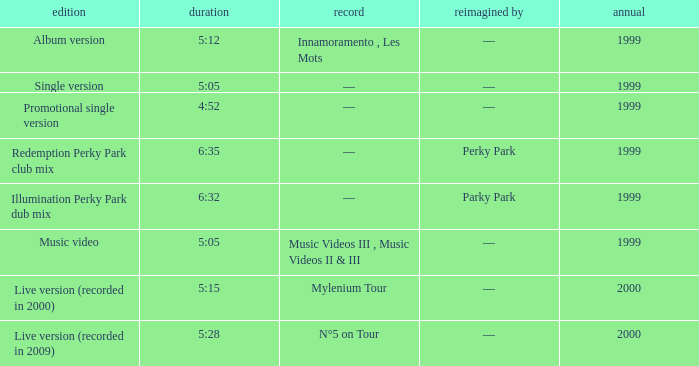What album is 5:15 long Live version (recorded in 2000). Write the full table. {'header': ['edition', 'duration', 'record', 'reimagined by', 'annual'], 'rows': [['Album version', '5:12', 'Innamoramento , Les Mots', '—', '1999'], ['Single version', '5:05', '—', '—', '1999'], ['Promotional single version', '4:52', '—', '—', '1999'], ['Redemption Perky Park club mix', '6:35', '—', 'Perky Park', '1999'], ['Illumination Perky Park dub mix', '6:32', '—', 'Parky Park', '1999'], ['Music video', '5:05', 'Music Videos III , Music Videos II & III', '—', '1999'], ['Live version (recorded in 2000)', '5:15', 'Mylenium Tour', '—', '2000'], ['Live version (recorded in 2009)', '5:28', 'N°5 on Tour', '—', '2000']]} 